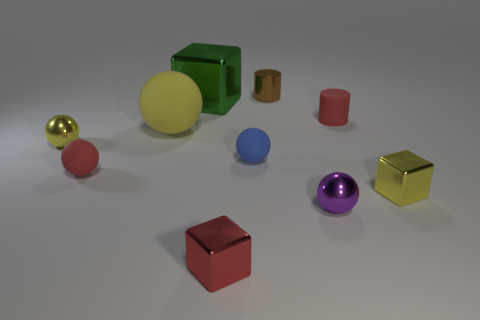Judging by the objects in the image, can you explain what the possible context or purpose of this scene might be? The scene looks like a composition arranged for a visual task such as a demonstration of color variety, shapes, textures, or for a visual discrimination study. 